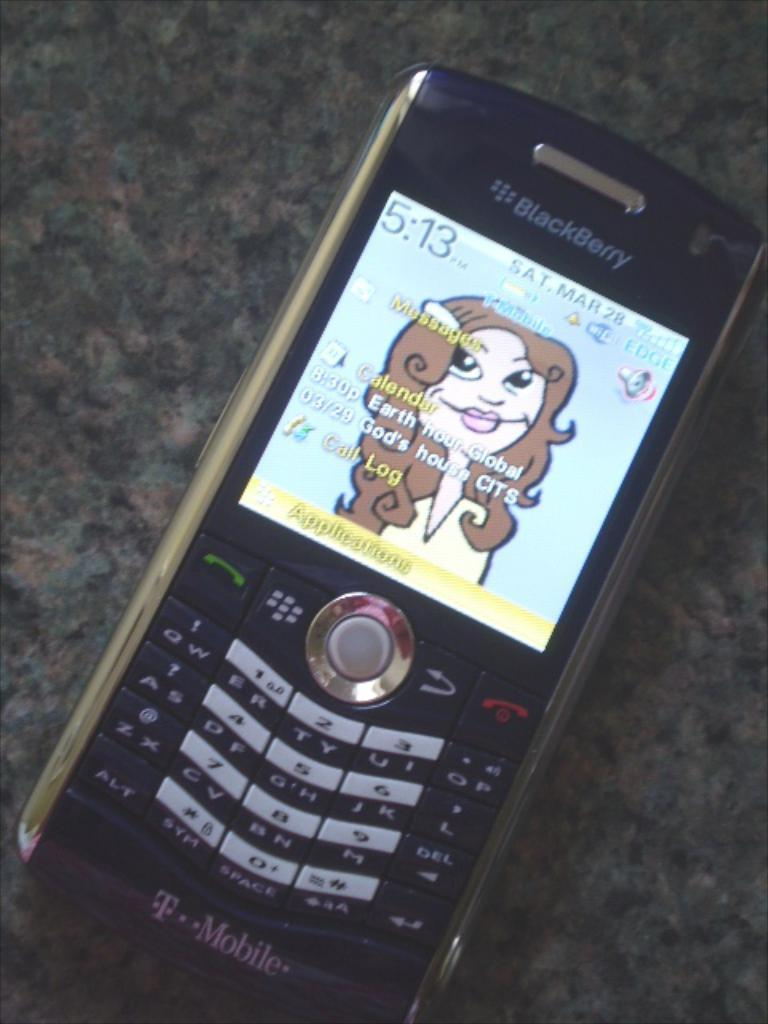<image>
Create a compact narrative representing the image presented. A T-Mobile phone displays the time as 5:13 PM on Mar 28. 